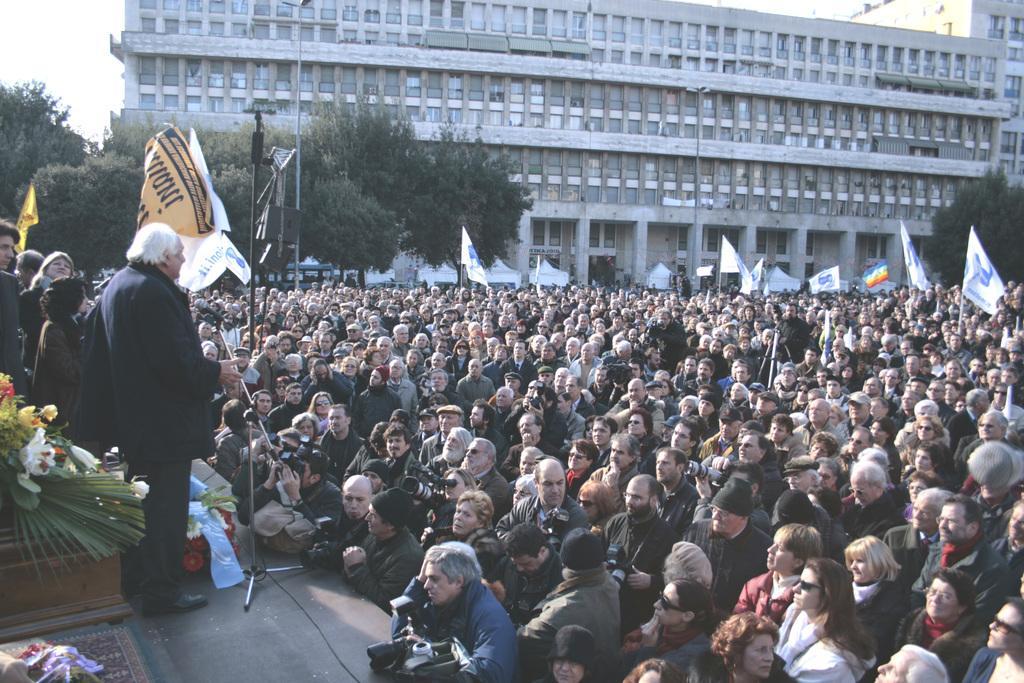Describe this image in one or two sentences. In this image at the bottom there are few people who are standing and on the right side there is a stage. On the stage there are some people who are standing and there are some boxes and flower bouquets and speakers, and also there are some poles and wires. In the background there is a building and some trees, at the bottom there are some people who are holding cameras. 